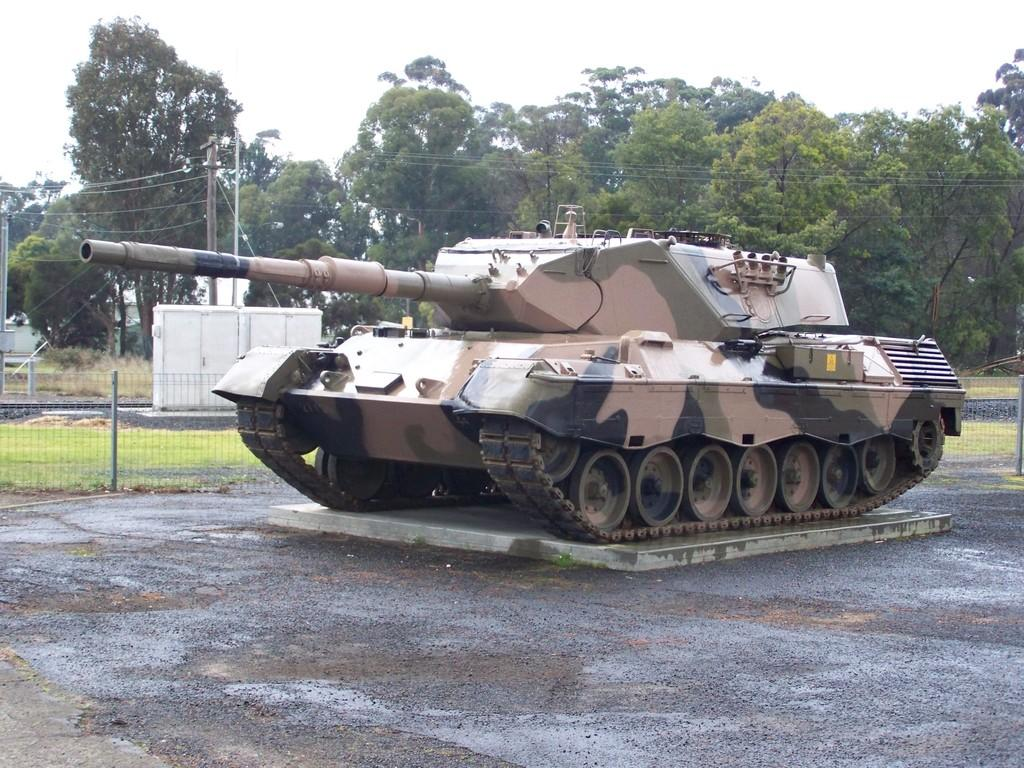What type of vehicle is in the image? There is a Churchill tank in the image. What can be seen in the foreground of the image? There is a fence in the image. What type of infrastructure is visible in the image? Electric boxes and a current pole with wires are visible in the image. What type of vegetation is present in the image? There are trees in the image. What is visible in the background of the image? The sky is visible in the background of the image. What is the price of the cast on the tank in the image? There is no cast on the tank in the image, and therefore no price can be determined. 